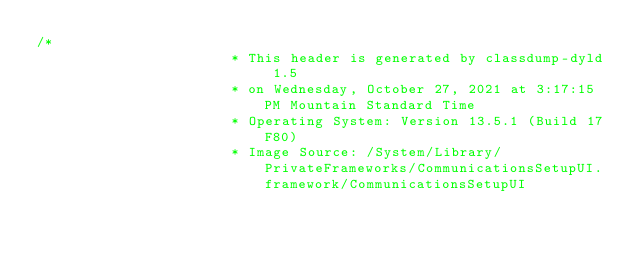<code> <loc_0><loc_0><loc_500><loc_500><_C_>/*
                       * This header is generated by classdump-dyld 1.5
                       * on Wednesday, October 27, 2021 at 3:17:15 PM Mountain Standard Time
                       * Operating System: Version 13.5.1 (Build 17F80)
                       * Image Source: /System/Library/PrivateFrameworks/CommunicationsSetupUI.framework/CommunicationsSetupUI</code> 